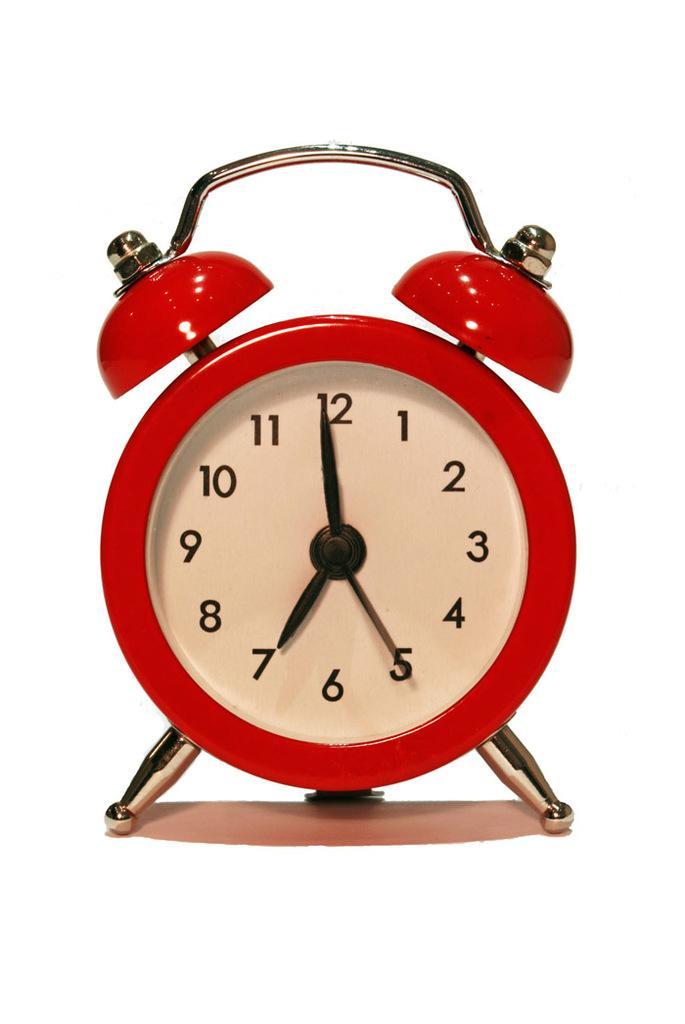Describe this image in one or two sentences. In this picture there is a red color clock. In the inside the clock there are numbers and there is a hour's hand, minute's hand and second's hand. At the back there is a white background. 